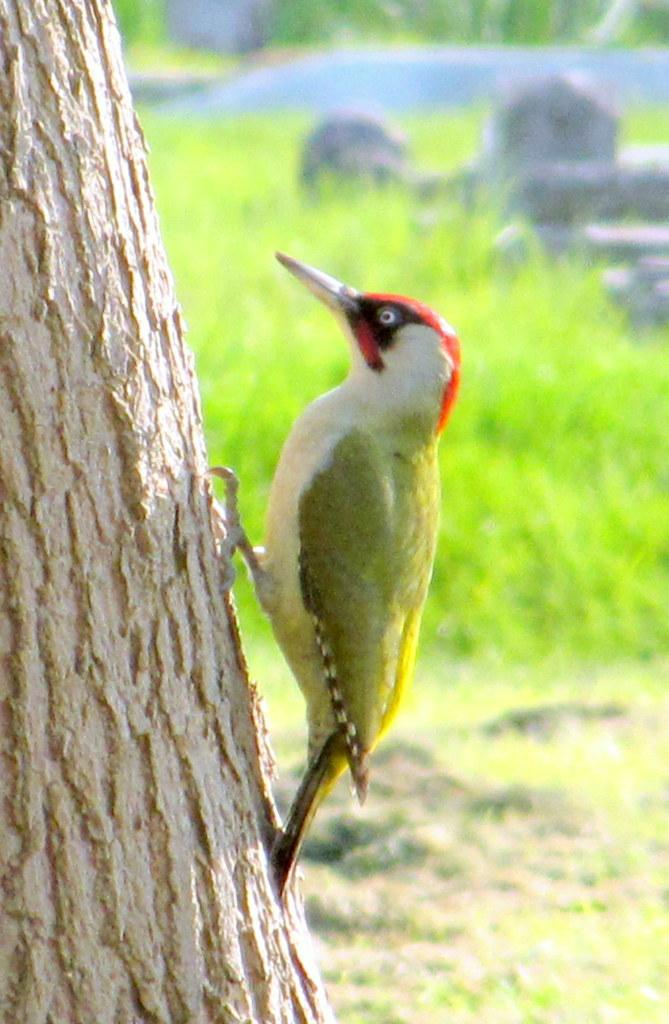What type of bird is in the image? There is a woodpecker in the image. What is the woodpecker standing on? The woodpecker is standing on a tree trunk. What can be seen in the background of the image? There is grass visible in the background of the image. What other objects are present in the image? There are rocks in the image. What type of linen is draped over the woodpecker in the image? There is no linen present in the image; the woodpecker is standing on a tree trunk. What rhythm is the woodpecker tapping out on the tree trunk in the image? Woodpeckers do not tap out rhythms; they peck at tree trunks to find insects. 